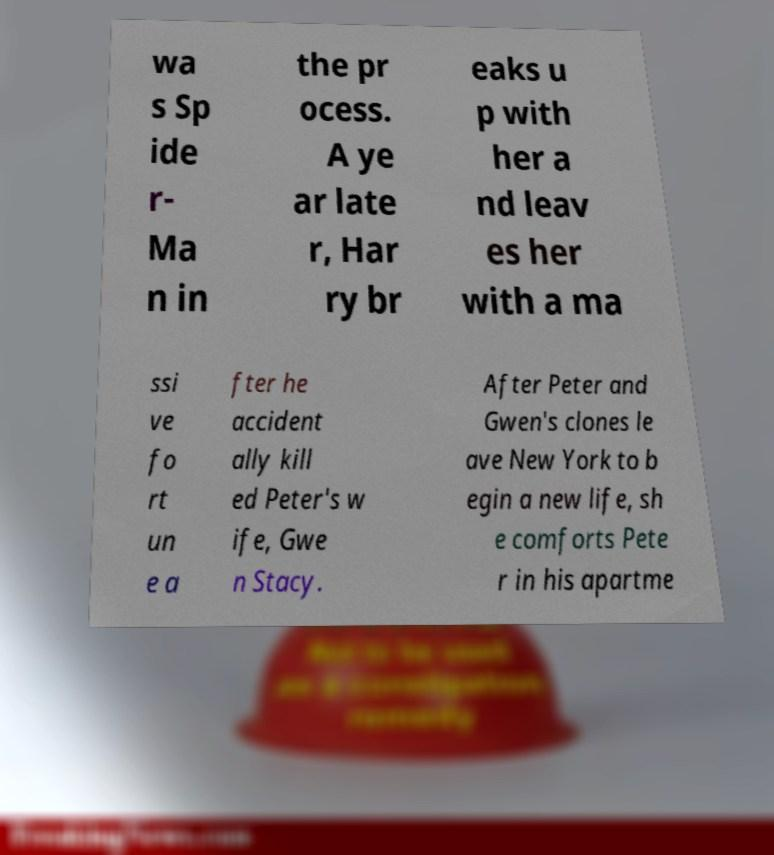Can you accurately transcribe the text from the provided image for me? wa s Sp ide r- Ma n in the pr ocess. A ye ar late r, Har ry br eaks u p with her a nd leav es her with a ma ssi ve fo rt un e a fter he accident ally kill ed Peter's w ife, Gwe n Stacy. After Peter and Gwen's clones le ave New York to b egin a new life, sh e comforts Pete r in his apartme 